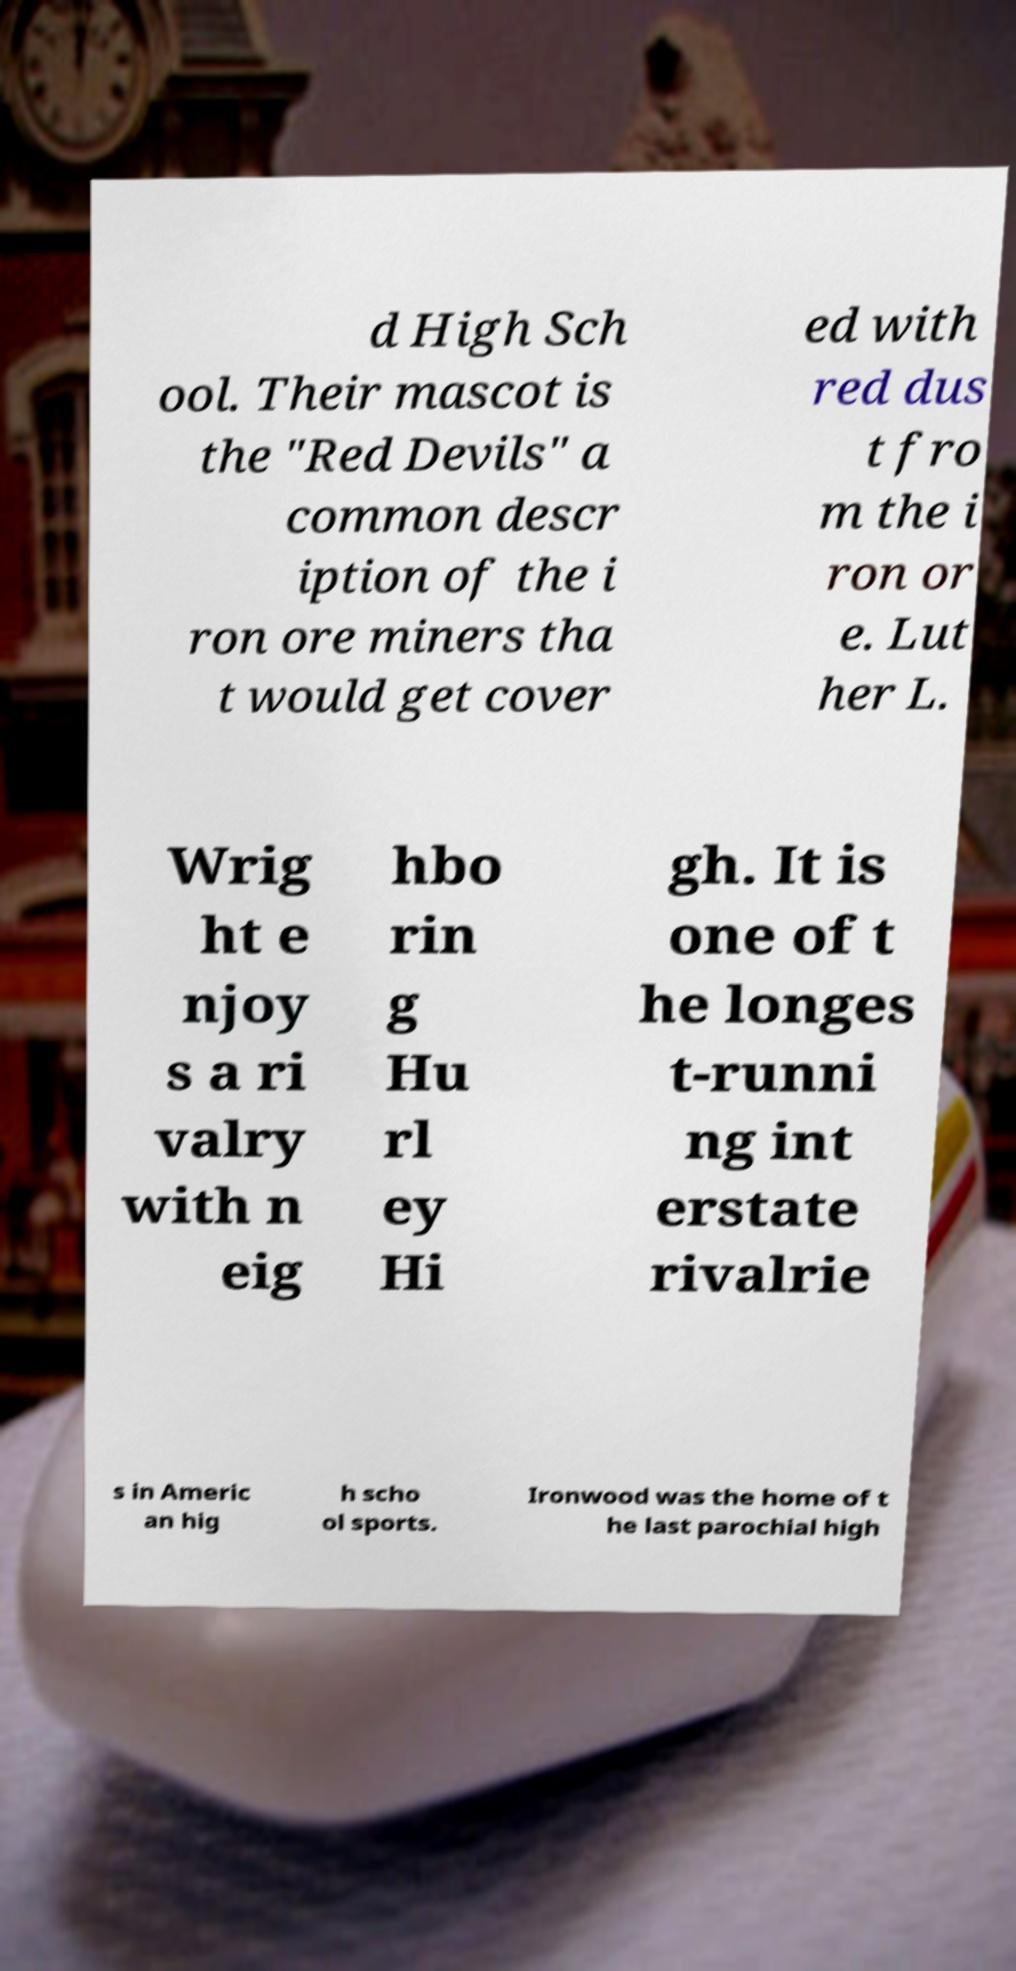Please read and relay the text visible in this image. What does it say? d High Sch ool. Their mascot is the "Red Devils" a common descr iption of the i ron ore miners tha t would get cover ed with red dus t fro m the i ron or e. Lut her L. Wrig ht e njoy s a ri valry with n eig hbo rin g Hu rl ey Hi gh. It is one of t he longes t-runni ng int erstate rivalrie s in Americ an hig h scho ol sports. Ironwood was the home of t he last parochial high 